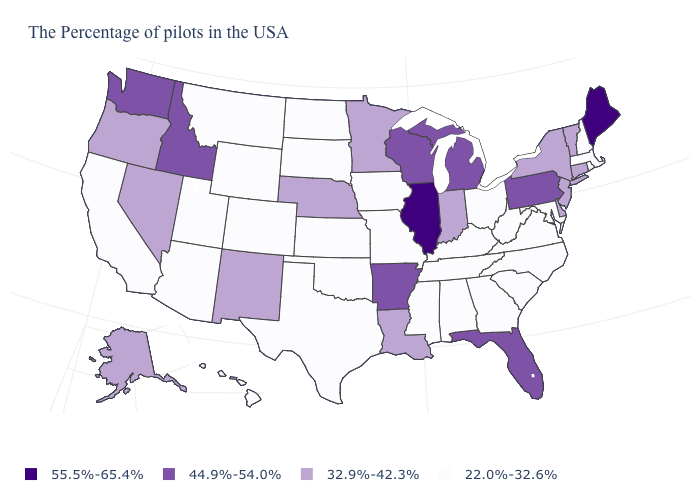What is the value of Pennsylvania?
Answer briefly. 44.9%-54.0%. What is the value of New Hampshire?
Concise answer only. 22.0%-32.6%. What is the lowest value in the USA?
Give a very brief answer. 22.0%-32.6%. What is the value of Florida?
Quick response, please. 44.9%-54.0%. Name the states that have a value in the range 22.0%-32.6%?
Answer briefly. Massachusetts, Rhode Island, New Hampshire, Maryland, Virginia, North Carolina, South Carolina, West Virginia, Ohio, Georgia, Kentucky, Alabama, Tennessee, Mississippi, Missouri, Iowa, Kansas, Oklahoma, Texas, South Dakota, North Dakota, Wyoming, Colorado, Utah, Montana, Arizona, California, Hawaii. Does the map have missing data?
Keep it brief. No. What is the highest value in the MidWest ?
Concise answer only. 55.5%-65.4%. Does the first symbol in the legend represent the smallest category?
Quick response, please. No. Name the states that have a value in the range 32.9%-42.3%?
Answer briefly. Vermont, Connecticut, New York, New Jersey, Delaware, Indiana, Louisiana, Minnesota, Nebraska, New Mexico, Nevada, Oregon, Alaska. Which states have the lowest value in the USA?
Quick response, please. Massachusetts, Rhode Island, New Hampshire, Maryland, Virginia, North Carolina, South Carolina, West Virginia, Ohio, Georgia, Kentucky, Alabama, Tennessee, Mississippi, Missouri, Iowa, Kansas, Oklahoma, Texas, South Dakota, North Dakota, Wyoming, Colorado, Utah, Montana, Arizona, California, Hawaii. What is the value of Texas?
Short answer required. 22.0%-32.6%. What is the lowest value in states that border Kansas?
Keep it brief. 22.0%-32.6%. Does Illinois have the highest value in the MidWest?
Keep it brief. Yes. Does Kansas have the same value as Vermont?
Write a very short answer. No. 